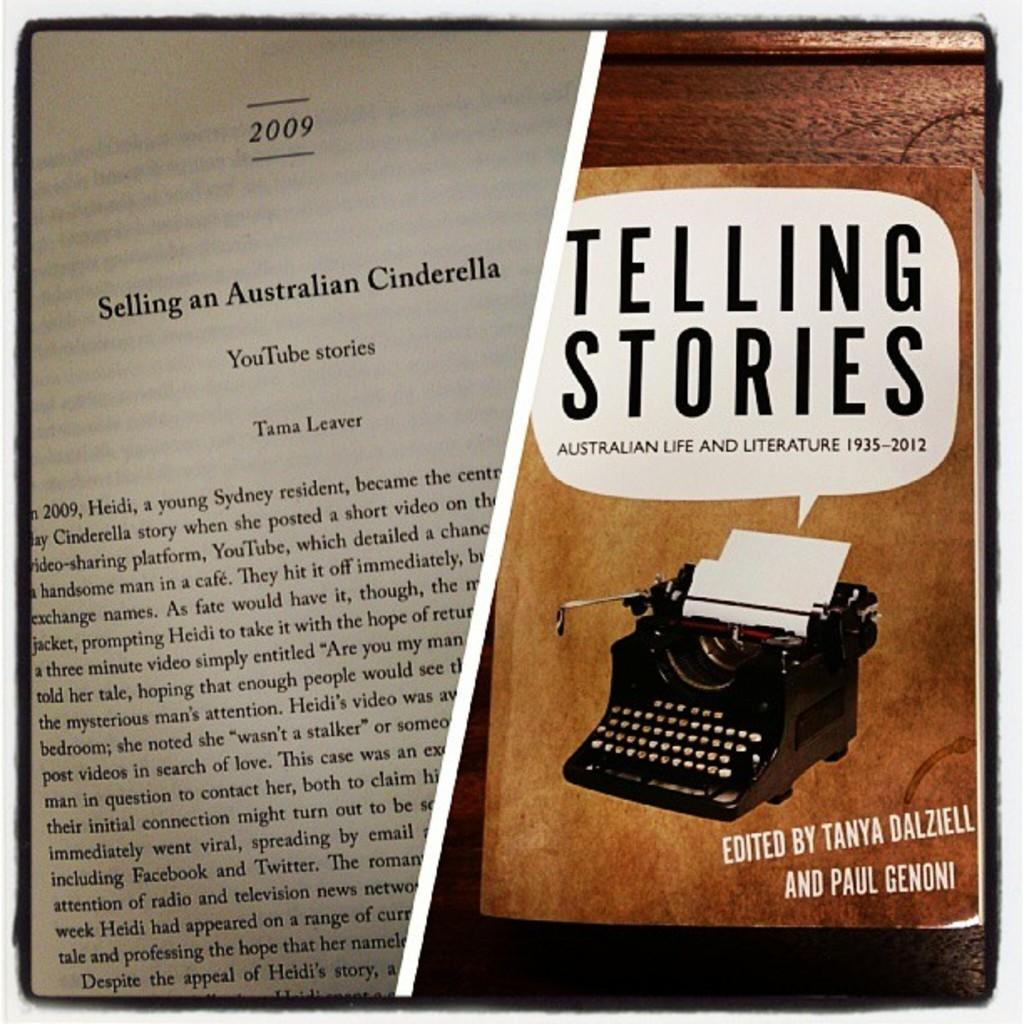<image>
Summarize the visual content of the image. The book shown is called Telling Stories from 1935 to 2012 